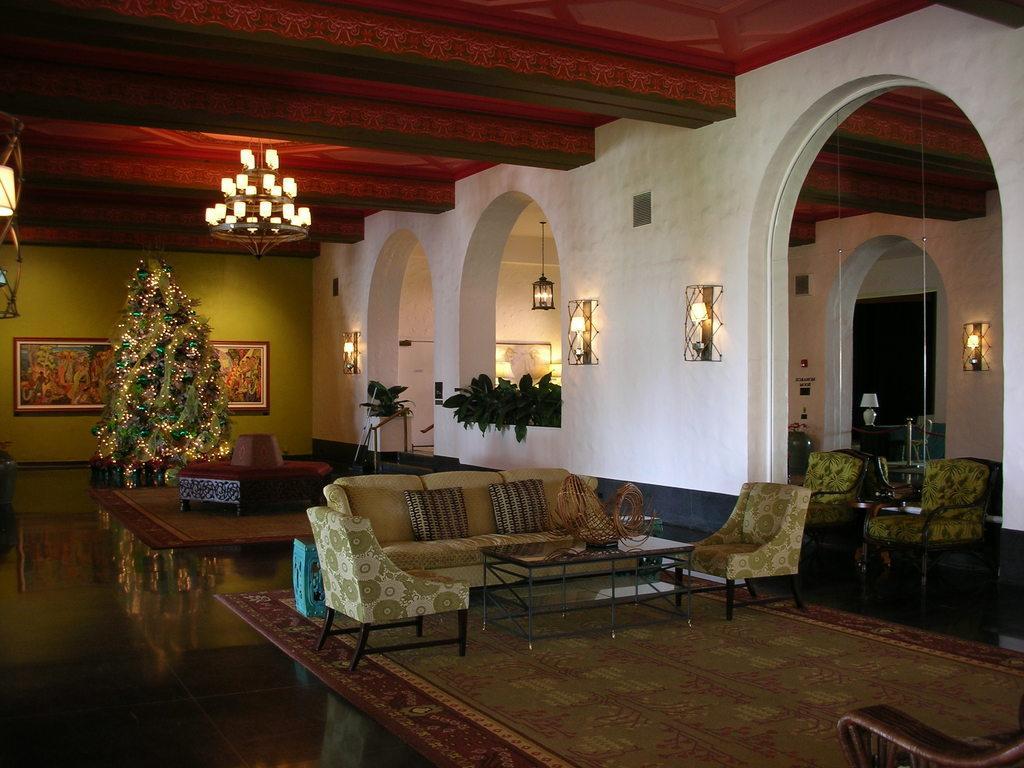Could you give a brief overview of what you see in this image? here is a room where we have some plants, sofas and a christmas tree in the corner and the lamp on the roof and the floor mats. 